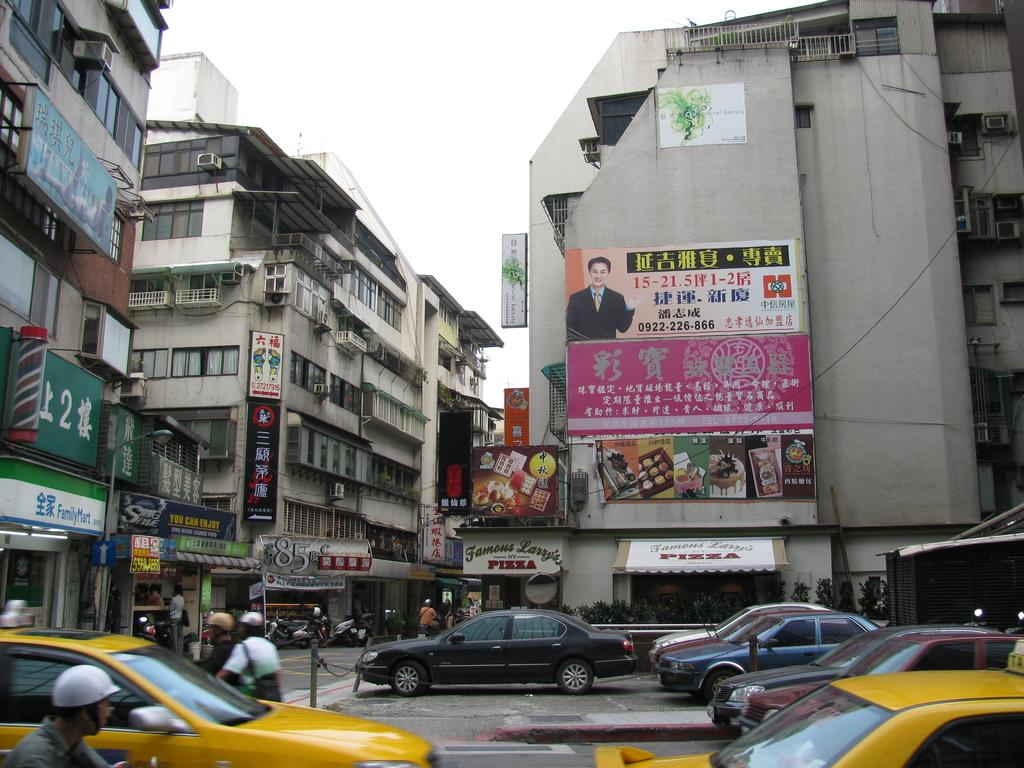<image>
Provide a brief description of the given image. Famous Larry's NY Pizza can be found on this street corner. 